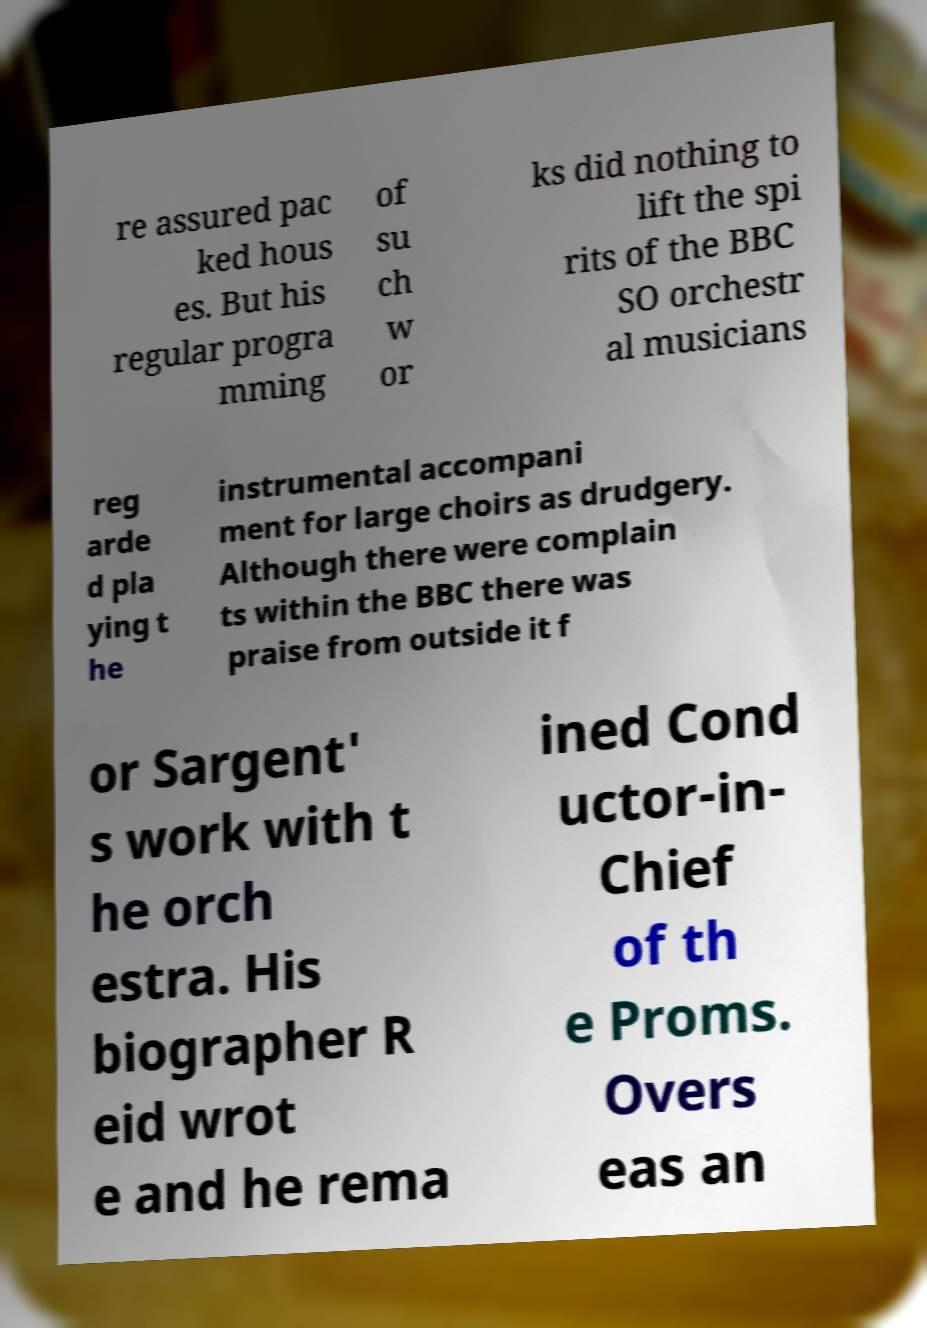What messages or text are displayed in this image? I need them in a readable, typed format. re assured pac ked hous es. But his regular progra mming of su ch w or ks did nothing to lift the spi rits of the BBC SO orchestr al musicians reg arde d pla ying t he instrumental accompani ment for large choirs as drudgery. Although there were complain ts within the BBC there was praise from outside it f or Sargent' s work with t he orch estra. His biographer R eid wrot e and he rema ined Cond uctor-in- Chief of th e Proms. Overs eas an 